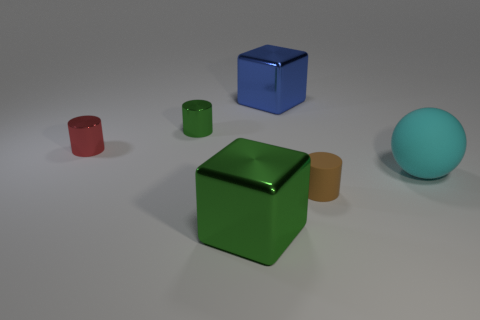Are there any spheres that have the same material as the big green object?
Your answer should be very brief. No. What number of objects are big cyan rubber objects or big green things?
Provide a short and direct response. 2. Do the tiny green thing and the big block behind the tiny red shiny cylinder have the same material?
Your answer should be very brief. Yes. There is a green object that is behind the tiny matte thing; what size is it?
Your response must be concise. Small. Is the number of gray spheres less than the number of tiny green cylinders?
Keep it short and to the point. Yes. Are there any cubes of the same color as the large sphere?
Your answer should be compact. No. The object that is behind the cyan thing and in front of the tiny green shiny cylinder has what shape?
Provide a succinct answer. Cylinder. The brown rubber thing that is on the right side of the metallic cylinder on the right side of the red metallic object is what shape?
Ensure brevity in your answer.  Cylinder. Does the tiny brown object have the same shape as the red metal thing?
Your answer should be very brief. Yes. Is the big sphere the same color as the tiny matte cylinder?
Offer a very short reply. No. 